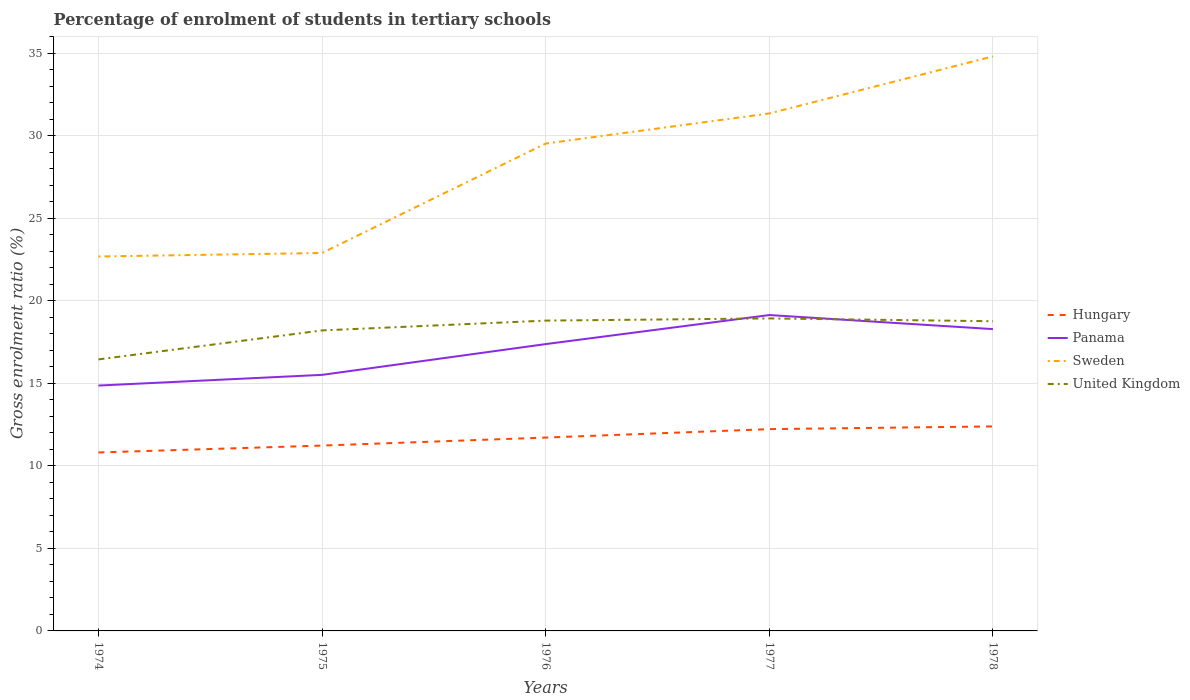Does the line corresponding to Sweden intersect with the line corresponding to Hungary?
Give a very brief answer. No. Is the number of lines equal to the number of legend labels?
Your response must be concise. Yes. Across all years, what is the maximum percentage of students enrolled in tertiary schools in Hungary?
Your answer should be compact. 10.81. In which year was the percentage of students enrolled in tertiary schools in Sweden maximum?
Provide a succinct answer. 1974. What is the total percentage of students enrolled in tertiary schools in United Kingdom in the graph?
Your answer should be compact. -0.13. What is the difference between the highest and the second highest percentage of students enrolled in tertiary schools in Hungary?
Keep it short and to the point. 1.58. Is the percentage of students enrolled in tertiary schools in Sweden strictly greater than the percentage of students enrolled in tertiary schools in United Kingdom over the years?
Provide a short and direct response. No. Does the graph contain any zero values?
Offer a very short reply. No. Where does the legend appear in the graph?
Keep it short and to the point. Center right. How many legend labels are there?
Provide a short and direct response. 4. What is the title of the graph?
Offer a very short reply. Percentage of enrolment of students in tertiary schools. Does "Bosnia and Herzegovina" appear as one of the legend labels in the graph?
Provide a short and direct response. No. What is the label or title of the X-axis?
Provide a succinct answer. Years. What is the label or title of the Y-axis?
Offer a terse response. Gross enrolment ratio (%). What is the Gross enrolment ratio (%) in Hungary in 1974?
Give a very brief answer. 10.81. What is the Gross enrolment ratio (%) of Panama in 1974?
Give a very brief answer. 14.87. What is the Gross enrolment ratio (%) in Sweden in 1974?
Offer a terse response. 22.69. What is the Gross enrolment ratio (%) of United Kingdom in 1974?
Offer a terse response. 16.45. What is the Gross enrolment ratio (%) of Hungary in 1975?
Give a very brief answer. 11.23. What is the Gross enrolment ratio (%) in Panama in 1975?
Offer a terse response. 15.51. What is the Gross enrolment ratio (%) of Sweden in 1975?
Provide a succinct answer. 22.9. What is the Gross enrolment ratio (%) of United Kingdom in 1975?
Ensure brevity in your answer.  18.21. What is the Gross enrolment ratio (%) of Hungary in 1976?
Offer a terse response. 11.72. What is the Gross enrolment ratio (%) in Panama in 1976?
Make the answer very short. 17.38. What is the Gross enrolment ratio (%) of Sweden in 1976?
Your response must be concise. 29.53. What is the Gross enrolment ratio (%) of United Kingdom in 1976?
Provide a succinct answer. 18.8. What is the Gross enrolment ratio (%) in Hungary in 1977?
Offer a very short reply. 12.23. What is the Gross enrolment ratio (%) of Panama in 1977?
Your answer should be compact. 19.14. What is the Gross enrolment ratio (%) in Sweden in 1977?
Provide a short and direct response. 31.35. What is the Gross enrolment ratio (%) of United Kingdom in 1977?
Make the answer very short. 18.93. What is the Gross enrolment ratio (%) of Hungary in 1978?
Keep it short and to the point. 12.39. What is the Gross enrolment ratio (%) in Panama in 1978?
Provide a succinct answer. 18.29. What is the Gross enrolment ratio (%) of Sweden in 1978?
Your answer should be compact. 34.81. What is the Gross enrolment ratio (%) in United Kingdom in 1978?
Your answer should be very brief. 18.76. Across all years, what is the maximum Gross enrolment ratio (%) of Hungary?
Offer a terse response. 12.39. Across all years, what is the maximum Gross enrolment ratio (%) of Panama?
Keep it short and to the point. 19.14. Across all years, what is the maximum Gross enrolment ratio (%) of Sweden?
Your response must be concise. 34.81. Across all years, what is the maximum Gross enrolment ratio (%) in United Kingdom?
Provide a succinct answer. 18.93. Across all years, what is the minimum Gross enrolment ratio (%) of Hungary?
Give a very brief answer. 10.81. Across all years, what is the minimum Gross enrolment ratio (%) in Panama?
Offer a very short reply. 14.87. Across all years, what is the minimum Gross enrolment ratio (%) of Sweden?
Provide a short and direct response. 22.69. Across all years, what is the minimum Gross enrolment ratio (%) in United Kingdom?
Ensure brevity in your answer.  16.45. What is the total Gross enrolment ratio (%) in Hungary in the graph?
Your answer should be very brief. 58.38. What is the total Gross enrolment ratio (%) in Panama in the graph?
Offer a terse response. 85.19. What is the total Gross enrolment ratio (%) in Sweden in the graph?
Keep it short and to the point. 141.28. What is the total Gross enrolment ratio (%) in United Kingdom in the graph?
Offer a terse response. 91.16. What is the difference between the Gross enrolment ratio (%) of Hungary in 1974 and that in 1975?
Your response must be concise. -0.42. What is the difference between the Gross enrolment ratio (%) in Panama in 1974 and that in 1975?
Offer a terse response. -0.65. What is the difference between the Gross enrolment ratio (%) in Sweden in 1974 and that in 1975?
Offer a terse response. -0.21. What is the difference between the Gross enrolment ratio (%) of United Kingdom in 1974 and that in 1975?
Offer a terse response. -1.76. What is the difference between the Gross enrolment ratio (%) of Hungary in 1974 and that in 1976?
Offer a very short reply. -0.9. What is the difference between the Gross enrolment ratio (%) of Panama in 1974 and that in 1976?
Give a very brief answer. -2.51. What is the difference between the Gross enrolment ratio (%) in Sweden in 1974 and that in 1976?
Offer a terse response. -6.84. What is the difference between the Gross enrolment ratio (%) of United Kingdom in 1974 and that in 1976?
Give a very brief answer. -2.35. What is the difference between the Gross enrolment ratio (%) of Hungary in 1974 and that in 1977?
Your response must be concise. -1.41. What is the difference between the Gross enrolment ratio (%) in Panama in 1974 and that in 1977?
Offer a terse response. -4.27. What is the difference between the Gross enrolment ratio (%) of Sweden in 1974 and that in 1977?
Your answer should be very brief. -8.67. What is the difference between the Gross enrolment ratio (%) of United Kingdom in 1974 and that in 1977?
Provide a short and direct response. -2.48. What is the difference between the Gross enrolment ratio (%) of Hungary in 1974 and that in 1978?
Your answer should be compact. -1.58. What is the difference between the Gross enrolment ratio (%) in Panama in 1974 and that in 1978?
Your response must be concise. -3.42. What is the difference between the Gross enrolment ratio (%) in Sweden in 1974 and that in 1978?
Your response must be concise. -12.12. What is the difference between the Gross enrolment ratio (%) of United Kingdom in 1974 and that in 1978?
Ensure brevity in your answer.  -2.31. What is the difference between the Gross enrolment ratio (%) in Hungary in 1975 and that in 1976?
Ensure brevity in your answer.  -0.49. What is the difference between the Gross enrolment ratio (%) in Panama in 1975 and that in 1976?
Offer a very short reply. -1.86. What is the difference between the Gross enrolment ratio (%) in Sweden in 1975 and that in 1976?
Your answer should be very brief. -6.63. What is the difference between the Gross enrolment ratio (%) of United Kingdom in 1975 and that in 1976?
Ensure brevity in your answer.  -0.59. What is the difference between the Gross enrolment ratio (%) in Hungary in 1975 and that in 1977?
Offer a very short reply. -1. What is the difference between the Gross enrolment ratio (%) in Panama in 1975 and that in 1977?
Make the answer very short. -3.62. What is the difference between the Gross enrolment ratio (%) of Sweden in 1975 and that in 1977?
Offer a very short reply. -8.45. What is the difference between the Gross enrolment ratio (%) in United Kingdom in 1975 and that in 1977?
Your answer should be compact. -0.73. What is the difference between the Gross enrolment ratio (%) of Hungary in 1975 and that in 1978?
Provide a short and direct response. -1.16. What is the difference between the Gross enrolment ratio (%) of Panama in 1975 and that in 1978?
Your answer should be compact. -2.77. What is the difference between the Gross enrolment ratio (%) in Sweden in 1975 and that in 1978?
Your response must be concise. -11.91. What is the difference between the Gross enrolment ratio (%) of United Kingdom in 1975 and that in 1978?
Keep it short and to the point. -0.56. What is the difference between the Gross enrolment ratio (%) in Hungary in 1976 and that in 1977?
Provide a succinct answer. -0.51. What is the difference between the Gross enrolment ratio (%) in Panama in 1976 and that in 1977?
Give a very brief answer. -1.76. What is the difference between the Gross enrolment ratio (%) of Sweden in 1976 and that in 1977?
Offer a terse response. -1.82. What is the difference between the Gross enrolment ratio (%) of United Kingdom in 1976 and that in 1977?
Give a very brief answer. -0.13. What is the difference between the Gross enrolment ratio (%) in Hungary in 1976 and that in 1978?
Provide a short and direct response. -0.68. What is the difference between the Gross enrolment ratio (%) in Panama in 1976 and that in 1978?
Your response must be concise. -0.91. What is the difference between the Gross enrolment ratio (%) of Sweden in 1976 and that in 1978?
Make the answer very short. -5.28. What is the difference between the Gross enrolment ratio (%) of United Kingdom in 1976 and that in 1978?
Provide a short and direct response. 0.04. What is the difference between the Gross enrolment ratio (%) of Hungary in 1977 and that in 1978?
Give a very brief answer. -0.16. What is the difference between the Gross enrolment ratio (%) in Panama in 1977 and that in 1978?
Keep it short and to the point. 0.85. What is the difference between the Gross enrolment ratio (%) in Sweden in 1977 and that in 1978?
Keep it short and to the point. -3.46. What is the difference between the Gross enrolment ratio (%) in United Kingdom in 1977 and that in 1978?
Offer a terse response. 0.17. What is the difference between the Gross enrolment ratio (%) in Hungary in 1974 and the Gross enrolment ratio (%) in Panama in 1975?
Your answer should be compact. -4.7. What is the difference between the Gross enrolment ratio (%) of Hungary in 1974 and the Gross enrolment ratio (%) of Sweden in 1975?
Offer a very short reply. -12.09. What is the difference between the Gross enrolment ratio (%) in Hungary in 1974 and the Gross enrolment ratio (%) in United Kingdom in 1975?
Your answer should be compact. -7.39. What is the difference between the Gross enrolment ratio (%) in Panama in 1974 and the Gross enrolment ratio (%) in Sweden in 1975?
Make the answer very short. -8.03. What is the difference between the Gross enrolment ratio (%) of Panama in 1974 and the Gross enrolment ratio (%) of United Kingdom in 1975?
Offer a terse response. -3.34. What is the difference between the Gross enrolment ratio (%) of Sweden in 1974 and the Gross enrolment ratio (%) of United Kingdom in 1975?
Your response must be concise. 4.48. What is the difference between the Gross enrolment ratio (%) in Hungary in 1974 and the Gross enrolment ratio (%) in Panama in 1976?
Provide a succinct answer. -6.57. What is the difference between the Gross enrolment ratio (%) of Hungary in 1974 and the Gross enrolment ratio (%) of Sweden in 1976?
Keep it short and to the point. -18.72. What is the difference between the Gross enrolment ratio (%) of Hungary in 1974 and the Gross enrolment ratio (%) of United Kingdom in 1976?
Your response must be concise. -7.99. What is the difference between the Gross enrolment ratio (%) in Panama in 1974 and the Gross enrolment ratio (%) in Sweden in 1976?
Provide a succinct answer. -14.66. What is the difference between the Gross enrolment ratio (%) of Panama in 1974 and the Gross enrolment ratio (%) of United Kingdom in 1976?
Provide a succinct answer. -3.94. What is the difference between the Gross enrolment ratio (%) in Sweden in 1974 and the Gross enrolment ratio (%) in United Kingdom in 1976?
Provide a short and direct response. 3.88. What is the difference between the Gross enrolment ratio (%) in Hungary in 1974 and the Gross enrolment ratio (%) in Panama in 1977?
Offer a very short reply. -8.33. What is the difference between the Gross enrolment ratio (%) of Hungary in 1974 and the Gross enrolment ratio (%) of Sweden in 1977?
Offer a very short reply. -20.54. What is the difference between the Gross enrolment ratio (%) in Hungary in 1974 and the Gross enrolment ratio (%) in United Kingdom in 1977?
Give a very brief answer. -8.12. What is the difference between the Gross enrolment ratio (%) of Panama in 1974 and the Gross enrolment ratio (%) of Sweden in 1977?
Ensure brevity in your answer.  -16.49. What is the difference between the Gross enrolment ratio (%) of Panama in 1974 and the Gross enrolment ratio (%) of United Kingdom in 1977?
Provide a short and direct response. -4.07. What is the difference between the Gross enrolment ratio (%) of Sweden in 1974 and the Gross enrolment ratio (%) of United Kingdom in 1977?
Provide a succinct answer. 3.75. What is the difference between the Gross enrolment ratio (%) in Hungary in 1974 and the Gross enrolment ratio (%) in Panama in 1978?
Your answer should be very brief. -7.47. What is the difference between the Gross enrolment ratio (%) in Hungary in 1974 and the Gross enrolment ratio (%) in Sweden in 1978?
Your answer should be compact. -24. What is the difference between the Gross enrolment ratio (%) of Hungary in 1974 and the Gross enrolment ratio (%) of United Kingdom in 1978?
Provide a short and direct response. -7.95. What is the difference between the Gross enrolment ratio (%) of Panama in 1974 and the Gross enrolment ratio (%) of Sweden in 1978?
Your answer should be very brief. -19.94. What is the difference between the Gross enrolment ratio (%) in Panama in 1974 and the Gross enrolment ratio (%) in United Kingdom in 1978?
Offer a very short reply. -3.9. What is the difference between the Gross enrolment ratio (%) of Sweden in 1974 and the Gross enrolment ratio (%) of United Kingdom in 1978?
Provide a succinct answer. 3.92. What is the difference between the Gross enrolment ratio (%) in Hungary in 1975 and the Gross enrolment ratio (%) in Panama in 1976?
Give a very brief answer. -6.15. What is the difference between the Gross enrolment ratio (%) in Hungary in 1975 and the Gross enrolment ratio (%) in Sweden in 1976?
Your answer should be very brief. -18.3. What is the difference between the Gross enrolment ratio (%) of Hungary in 1975 and the Gross enrolment ratio (%) of United Kingdom in 1976?
Ensure brevity in your answer.  -7.57. What is the difference between the Gross enrolment ratio (%) of Panama in 1975 and the Gross enrolment ratio (%) of Sweden in 1976?
Ensure brevity in your answer.  -14.02. What is the difference between the Gross enrolment ratio (%) of Panama in 1975 and the Gross enrolment ratio (%) of United Kingdom in 1976?
Provide a short and direct response. -3.29. What is the difference between the Gross enrolment ratio (%) of Sweden in 1975 and the Gross enrolment ratio (%) of United Kingdom in 1976?
Provide a short and direct response. 4.1. What is the difference between the Gross enrolment ratio (%) in Hungary in 1975 and the Gross enrolment ratio (%) in Panama in 1977?
Offer a terse response. -7.91. What is the difference between the Gross enrolment ratio (%) of Hungary in 1975 and the Gross enrolment ratio (%) of Sweden in 1977?
Keep it short and to the point. -20.12. What is the difference between the Gross enrolment ratio (%) in Hungary in 1975 and the Gross enrolment ratio (%) in United Kingdom in 1977?
Your answer should be compact. -7.7. What is the difference between the Gross enrolment ratio (%) in Panama in 1975 and the Gross enrolment ratio (%) in Sweden in 1977?
Your response must be concise. -15.84. What is the difference between the Gross enrolment ratio (%) in Panama in 1975 and the Gross enrolment ratio (%) in United Kingdom in 1977?
Provide a short and direct response. -3.42. What is the difference between the Gross enrolment ratio (%) of Sweden in 1975 and the Gross enrolment ratio (%) of United Kingdom in 1977?
Ensure brevity in your answer.  3.97. What is the difference between the Gross enrolment ratio (%) of Hungary in 1975 and the Gross enrolment ratio (%) of Panama in 1978?
Your response must be concise. -7.06. What is the difference between the Gross enrolment ratio (%) of Hungary in 1975 and the Gross enrolment ratio (%) of Sweden in 1978?
Your answer should be very brief. -23.58. What is the difference between the Gross enrolment ratio (%) of Hungary in 1975 and the Gross enrolment ratio (%) of United Kingdom in 1978?
Provide a succinct answer. -7.53. What is the difference between the Gross enrolment ratio (%) of Panama in 1975 and the Gross enrolment ratio (%) of Sweden in 1978?
Your answer should be compact. -19.3. What is the difference between the Gross enrolment ratio (%) in Panama in 1975 and the Gross enrolment ratio (%) in United Kingdom in 1978?
Offer a terse response. -3.25. What is the difference between the Gross enrolment ratio (%) of Sweden in 1975 and the Gross enrolment ratio (%) of United Kingdom in 1978?
Ensure brevity in your answer.  4.13. What is the difference between the Gross enrolment ratio (%) of Hungary in 1976 and the Gross enrolment ratio (%) of Panama in 1977?
Your response must be concise. -7.42. What is the difference between the Gross enrolment ratio (%) of Hungary in 1976 and the Gross enrolment ratio (%) of Sweden in 1977?
Your answer should be very brief. -19.64. What is the difference between the Gross enrolment ratio (%) of Hungary in 1976 and the Gross enrolment ratio (%) of United Kingdom in 1977?
Make the answer very short. -7.22. What is the difference between the Gross enrolment ratio (%) of Panama in 1976 and the Gross enrolment ratio (%) of Sweden in 1977?
Provide a short and direct response. -13.98. What is the difference between the Gross enrolment ratio (%) of Panama in 1976 and the Gross enrolment ratio (%) of United Kingdom in 1977?
Make the answer very short. -1.56. What is the difference between the Gross enrolment ratio (%) of Sweden in 1976 and the Gross enrolment ratio (%) of United Kingdom in 1977?
Provide a succinct answer. 10.6. What is the difference between the Gross enrolment ratio (%) of Hungary in 1976 and the Gross enrolment ratio (%) of Panama in 1978?
Keep it short and to the point. -6.57. What is the difference between the Gross enrolment ratio (%) in Hungary in 1976 and the Gross enrolment ratio (%) in Sweden in 1978?
Make the answer very short. -23.1. What is the difference between the Gross enrolment ratio (%) in Hungary in 1976 and the Gross enrolment ratio (%) in United Kingdom in 1978?
Provide a short and direct response. -7.05. What is the difference between the Gross enrolment ratio (%) in Panama in 1976 and the Gross enrolment ratio (%) in Sweden in 1978?
Your answer should be very brief. -17.43. What is the difference between the Gross enrolment ratio (%) in Panama in 1976 and the Gross enrolment ratio (%) in United Kingdom in 1978?
Give a very brief answer. -1.39. What is the difference between the Gross enrolment ratio (%) of Sweden in 1976 and the Gross enrolment ratio (%) of United Kingdom in 1978?
Offer a very short reply. 10.77. What is the difference between the Gross enrolment ratio (%) of Hungary in 1977 and the Gross enrolment ratio (%) of Panama in 1978?
Offer a terse response. -6.06. What is the difference between the Gross enrolment ratio (%) in Hungary in 1977 and the Gross enrolment ratio (%) in Sweden in 1978?
Offer a terse response. -22.58. What is the difference between the Gross enrolment ratio (%) in Hungary in 1977 and the Gross enrolment ratio (%) in United Kingdom in 1978?
Make the answer very short. -6.54. What is the difference between the Gross enrolment ratio (%) of Panama in 1977 and the Gross enrolment ratio (%) of Sweden in 1978?
Your response must be concise. -15.67. What is the difference between the Gross enrolment ratio (%) of Panama in 1977 and the Gross enrolment ratio (%) of United Kingdom in 1978?
Provide a succinct answer. 0.37. What is the difference between the Gross enrolment ratio (%) in Sweden in 1977 and the Gross enrolment ratio (%) in United Kingdom in 1978?
Make the answer very short. 12.59. What is the average Gross enrolment ratio (%) in Hungary per year?
Your answer should be compact. 11.68. What is the average Gross enrolment ratio (%) of Panama per year?
Ensure brevity in your answer.  17.04. What is the average Gross enrolment ratio (%) in Sweden per year?
Offer a very short reply. 28.26. What is the average Gross enrolment ratio (%) in United Kingdom per year?
Make the answer very short. 18.23. In the year 1974, what is the difference between the Gross enrolment ratio (%) in Hungary and Gross enrolment ratio (%) in Panama?
Your response must be concise. -4.05. In the year 1974, what is the difference between the Gross enrolment ratio (%) of Hungary and Gross enrolment ratio (%) of Sweden?
Provide a succinct answer. -11.87. In the year 1974, what is the difference between the Gross enrolment ratio (%) in Hungary and Gross enrolment ratio (%) in United Kingdom?
Ensure brevity in your answer.  -5.64. In the year 1974, what is the difference between the Gross enrolment ratio (%) of Panama and Gross enrolment ratio (%) of Sweden?
Provide a short and direct response. -7.82. In the year 1974, what is the difference between the Gross enrolment ratio (%) of Panama and Gross enrolment ratio (%) of United Kingdom?
Keep it short and to the point. -1.58. In the year 1974, what is the difference between the Gross enrolment ratio (%) of Sweden and Gross enrolment ratio (%) of United Kingdom?
Provide a succinct answer. 6.24. In the year 1975, what is the difference between the Gross enrolment ratio (%) in Hungary and Gross enrolment ratio (%) in Panama?
Provide a succinct answer. -4.28. In the year 1975, what is the difference between the Gross enrolment ratio (%) of Hungary and Gross enrolment ratio (%) of Sweden?
Ensure brevity in your answer.  -11.67. In the year 1975, what is the difference between the Gross enrolment ratio (%) of Hungary and Gross enrolment ratio (%) of United Kingdom?
Your answer should be compact. -6.98. In the year 1975, what is the difference between the Gross enrolment ratio (%) in Panama and Gross enrolment ratio (%) in Sweden?
Keep it short and to the point. -7.38. In the year 1975, what is the difference between the Gross enrolment ratio (%) of Panama and Gross enrolment ratio (%) of United Kingdom?
Offer a very short reply. -2.69. In the year 1975, what is the difference between the Gross enrolment ratio (%) of Sweden and Gross enrolment ratio (%) of United Kingdom?
Keep it short and to the point. 4.69. In the year 1976, what is the difference between the Gross enrolment ratio (%) in Hungary and Gross enrolment ratio (%) in Panama?
Keep it short and to the point. -5.66. In the year 1976, what is the difference between the Gross enrolment ratio (%) in Hungary and Gross enrolment ratio (%) in Sweden?
Ensure brevity in your answer.  -17.82. In the year 1976, what is the difference between the Gross enrolment ratio (%) of Hungary and Gross enrolment ratio (%) of United Kingdom?
Ensure brevity in your answer.  -7.09. In the year 1976, what is the difference between the Gross enrolment ratio (%) in Panama and Gross enrolment ratio (%) in Sweden?
Provide a succinct answer. -12.15. In the year 1976, what is the difference between the Gross enrolment ratio (%) of Panama and Gross enrolment ratio (%) of United Kingdom?
Keep it short and to the point. -1.42. In the year 1976, what is the difference between the Gross enrolment ratio (%) in Sweden and Gross enrolment ratio (%) in United Kingdom?
Offer a very short reply. 10.73. In the year 1977, what is the difference between the Gross enrolment ratio (%) in Hungary and Gross enrolment ratio (%) in Panama?
Keep it short and to the point. -6.91. In the year 1977, what is the difference between the Gross enrolment ratio (%) in Hungary and Gross enrolment ratio (%) in Sweden?
Offer a terse response. -19.13. In the year 1977, what is the difference between the Gross enrolment ratio (%) of Hungary and Gross enrolment ratio (%) of United Kingdom?
Your answer should be compact. -6.71. In the year 1977, what is the difference between the Gross enrolment ratio (%) in Panama and Gross enrolment ratio (%) in Sweden?
Your answer should be very brief. -12.22. In the year 1977, what is the difference between the Gross enrolment ratio (%) in Panama and Gross enrolment ratio (%) in United Kingdom?
Keep it short and to the point. 0.2. In the year 1977, what is the difference between the Gross enrolment ratio (%) of Sweden and Gross enrolment ratio (%) of United Kingdom?
Provide a short and direct response. 12.42. In the year 1978, what is the difference between the Gross enrolment ratio (%) of Hungary and Gross enrolment ratio (%) of Panama?
Make the answer very short. -5.9. In the year 1978, what is the difference between the Gross enrolment ratio (%) in Hungary and Gross enrolment ratio (%) in Sweden?
Make the answer very short. -22.42. In the year 1978, what is the difference between the Gross enrolment ratio (%) in Hungary and Gross enrolment ratio (%) in United Kingdom?
Keep it short and to the point. -6.37. In the year 1978, what is the difference between the Gross enrolment ratio (%) of Panama and Gross enrolment ratio (%) of Sweden?
Offer a very short reply. -16.52. In the year 1978, what is the difference between the Gross enrolment ratio (%) of Panama and Gross enrolment ratio (%) of United Kingdom?
Keep it short and to the point. -0.48. In the year 1978, what is the difference between the Gross enrolment ratio (%) of Sweden and Gross enrolment ratio (%) of United Kingdom?
Offer a terse response. 16.05. What is the ratio of the Gross enrolment ratio (%) of Hungary in 1974 to that in 1975?
Ensure brevity in your answer.  0.96. What is the ratio of the Gross enrolment ratio (%) in Panama in 1974 to that in 1975?
Your answer should be very brief. 0.96. What is the ratio of the Gross enrolment ratio (%) in Sweden in 1974 to that in 1975?
Offer a very short reply. 0.99. What is the ratio of the Gross enrolment ratio (%) of United Kingdom in 1974 to that in 1975?
Your answer should be compact. 0.9. What is the ratio of the Gross enrolment ratio (%) in Hungary in 1974 to that in 1976?
Provide a short and direct response. 0.92. What is the ratio of the Gross enrolment ratio (%) in Panama in 1974 to that in 1976?
Keep it short and to the point. 0.86. What is the ratio of the Gross enrolment ratio (%) of Sweden in 1974 to that in 1976?
Your answer should be very brief. 0.77. What is the ratio of the Gross enrolment ratio (%) in Hungary in 1974 to that in 1977?
Keep it short and to the point. 0.88. What is the ratio of the Gross enrolment ratio (%) of Panama in 1974 to that in 1977?
Provide a succinct answer. 0.78. What is the ratio of the Gross enrolment ratio (%) in Sweden in 1974 to that in 1977?
Ensure brevity in your answer.  0.72. What is the ratio of the Gross enrolment ratio (%) in United Kingdom in 1974 to that in 1977?
Your answer should be very brief. 0.87. What is the ratio of the Gross enrolment ratio (%) of Hungary in 1974 to that in 1978?
Provide a short and direct response. 0.87. What is the ratio of the Gross enrolment ratio (%) of Panama in 1974 to that in 1978?
Provide a short and direct response. 0.81. What is the ratio of the Gross enrolment ratio (%) of Sweden in 1974 to that in 1978?
Provide a short and direct response. 0.65. What is the ratio of the Gross enrolment ratio (%) of United Kingdom in 1974 to that in 1978?
Make the answer very short. 0.88. What is the ratio of the Gross enrolment ratio (%) of Hungary in 1975 to that in 1976?
Give a very brief answer. 0.96. What is the ratio of the Gross enrolment ratio (%) of Panama in 1975 to that in 1976?
Provide a succinct answer. 0.89. What is the ratio of the Gross enrolment ratio (%) of Sweden in 1975 to that in 1976?
Make the answer very short. 0.78. What is the ratio of the Gross enrolment ratio (%) of United Kingdom in 1975 to that in 1976?
Give a very brief answer. 0.97. What is the ratio of the Gross enrolment ratio (%) in Hungary in 1975 to that in 1977?
Offer a terse response. 0.92. What is the ratio of the Gross enrolment ratio (%) of Panama in 1975 to that in 1977?
Make the answer very short. 0.81. What is the ratio of the Gross enrolment ratio (%) in Sweden in 1975 to that in 1977?
Ensure brevity in your answer.  0.73. What is the ratio of the Gross enrolment ratio (%) in United Kingdom in 1975 to that in 1977?
Your answer should be very brief. 0.96. What is the ratio of the Gross enrolment ratio (%) of Hungary in 1975 to that in 1978?
Provide a short and direct response. 0.91. What is the ratio of the Gross enrolment ratio (%) of Panama in 1975 to that in 1978?
Your answer should be very brief. 0.85. What is the ratio of the Gross enrolment ratio (%) in Sweden in 1975 to that in 1978?
Your answer should be very brief. 0.66. What is the ratio of the Gross enrolment ratio (%) of United Kingdom in 1975 to that in 1978?
Keep it short and to the point. 0.97. What is the ratio of the Gross enrolment ratio (%) in Hungary in 1976 to that in 1977?
Your answer should be very brief. 0.96. What is the ratio of the Gross enrolment ratio (%) of Panama in 1976 to that in 1977?
Your answer should be very brief. 0.91. What is the ratio of the Gross enrolment ratio (%) in Sweden in 1976 to that in 1977?
Your answer should be compact. 0.94. What is the ratio of the Gross enrolment ratio (%) in United Kingdom in 1976 to that in 1977?
Make the answer very short. 0.99. What is the ratio of the Gross enrolment ratio (%) in Hungary in 1976 to that in 1978?
Provide a succinct answer. 0.95. What is the ratio of the Gross enrolment ratio (%) in Panama in 1976 to that in 1978?
Offer a very short reply. 0.95. What is the ratio of the Gross enrolment ratio (%) in Sweden in 1976 to that in 1978?
Keep it short and to the point. 0.85. What is the ratio of the Gross enrolment ratio (%) of United Kingdom in 1976 to that in 1978?
Provide a short and direct response. 1. What is the ratio of the Gross enrolment ratio (%) in Hungary in 1977 to that in 1978?
Your response must be concise. 0.99. What is the ratio of the Gross enrolment ratio (%) in Panama in 1977 to that in 1978?
Offer a terse response. 1.05. What is the ratio of the Gross enrolment ratio (%) in Sweden in 1977 to that in 1978?
Offer a terse response. 0.9. What is the ratio of the Gross enrolment ratio (%) in United Kingdom in 1977 to that in 1978?
Provide a succinct answer. 1.01. What is the difference between the highest and the second highest Gross enrolment ratio (%) in Hungary?
Keep it short and to the point. 0.16. What is the difference between the highest and the second highest Gross enrolment ratio (%) of Panama?
Make the answer very short. 0.85. What is the difference between the highest and the second highest Gross enrolment ratio (%) of Sweden?
Your response must be concise. 3.46. What is the difference between the highest and the second highest Gross enrolment ratio (%) of United Kingdom?
Offer a terse response. 0.13. What is the difference between the highest and the lowest Gross enrolment ratio (%) in Hungary?
Keep it short and to the point. 1.58. What is the difference between the highest and the lowest Gross enrolment ratio (%) in Panama?
Your answer should be very brief. 4.27. What is the difference between the highest and the lowest Gross enrolment ratio (%) of Sweden?
Make the answer very short. 12.12. What is the difference between the highest and the lowest Gross enrolment ratio (%) in United Kingdom?
Offer a terse response. 2.48. 